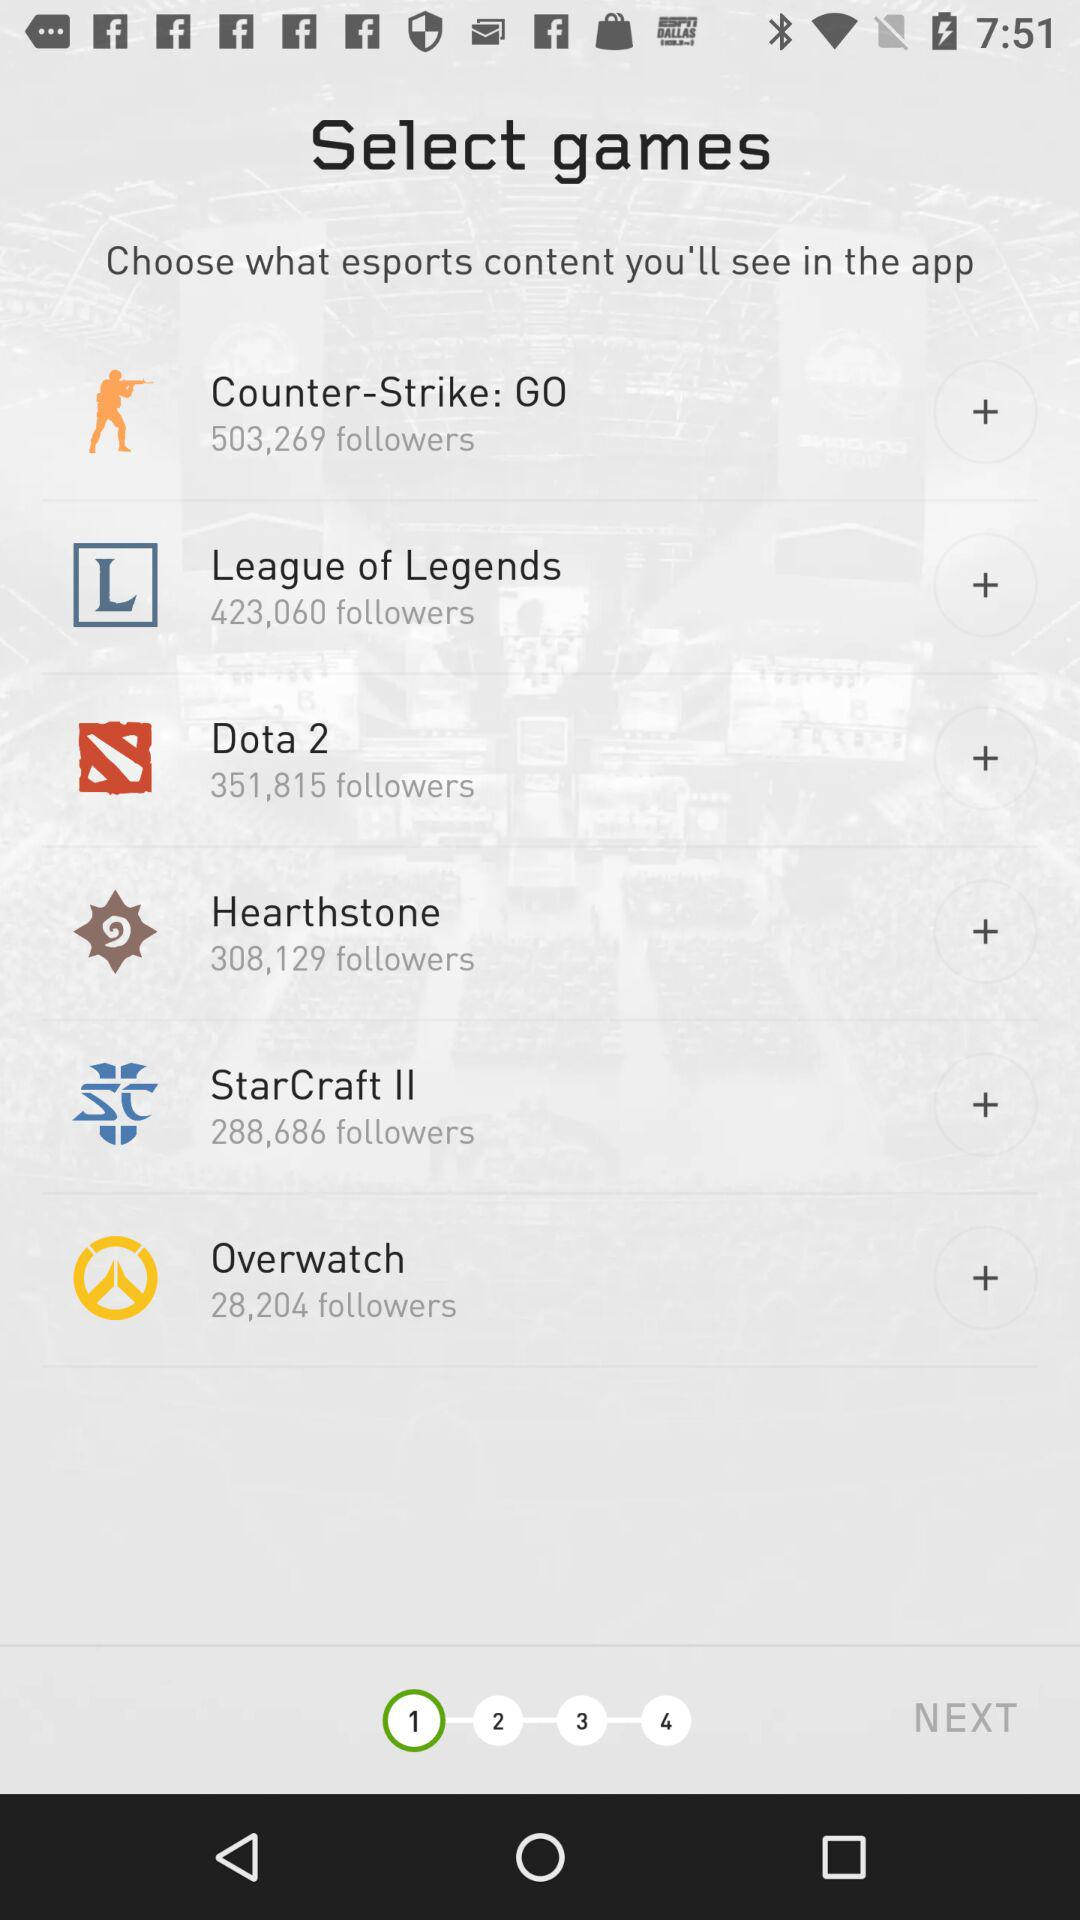How many games have fewer than 400,000 followers?
Answer the question using a single word or phrase. 4 